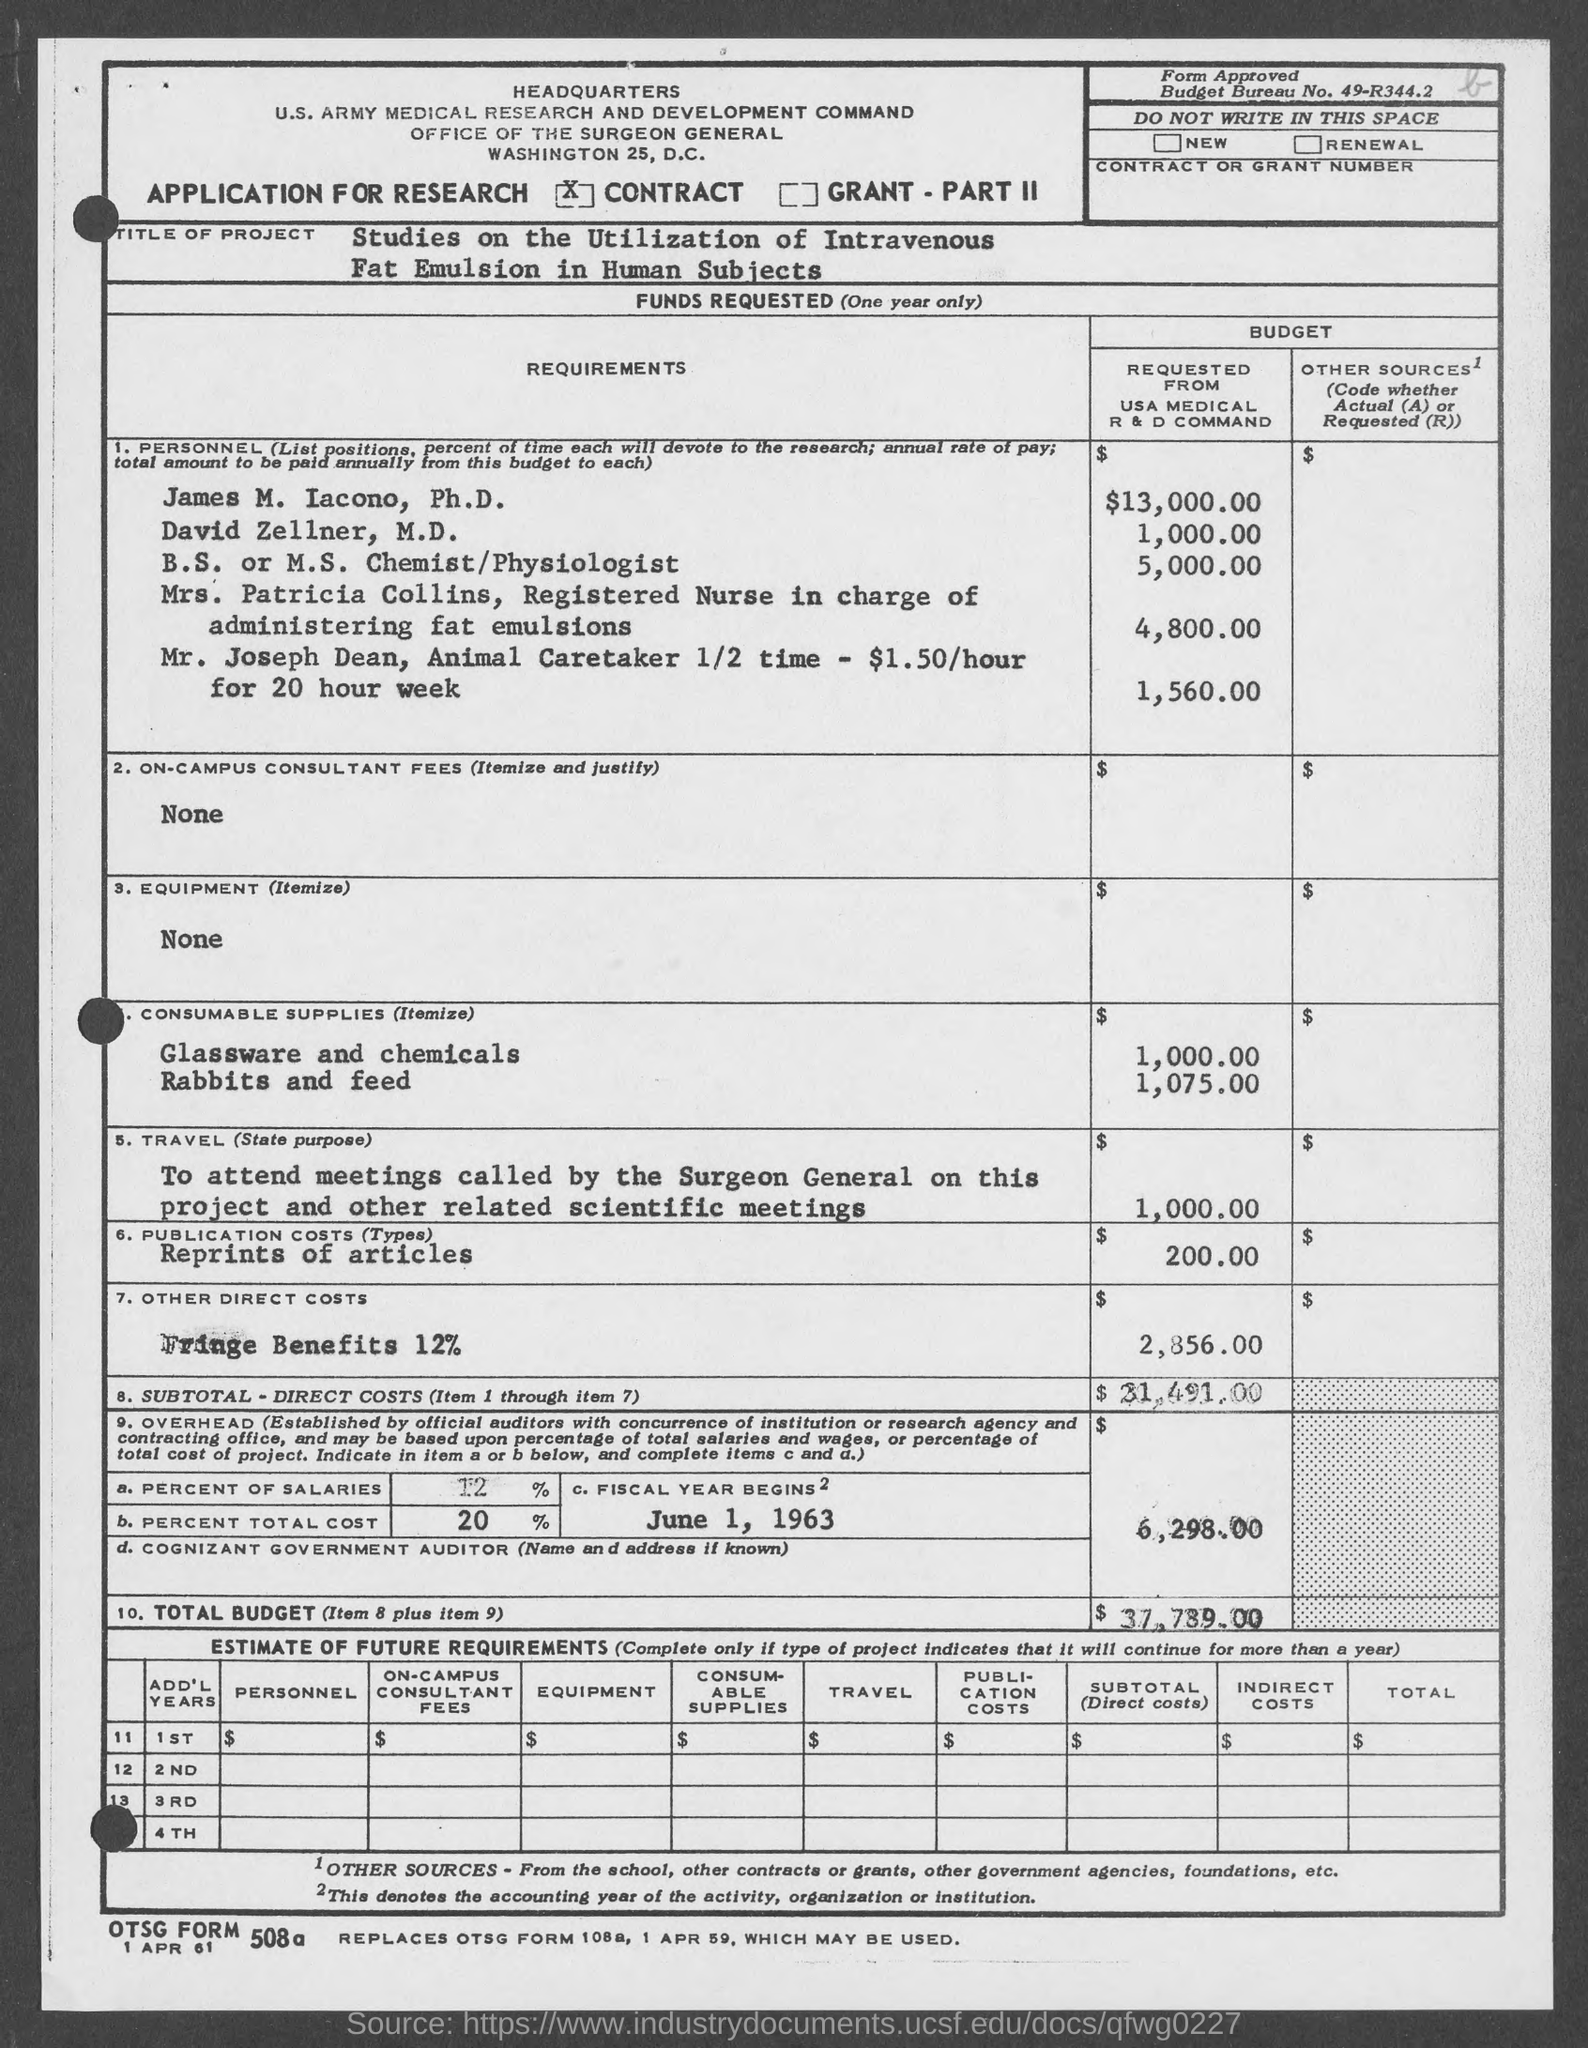Point out several critical features in this image. James M. Iacono, Ph.D. submitted a request for $13,000.00 from the USA Medical R&D Command. According to the request made by David Zellner, M.D., he requested a total of $1,000.00 from the USA Medical R&D Command. Mr. Joseph Dean requested 1,560.00 from the USA medical R&D Command. 